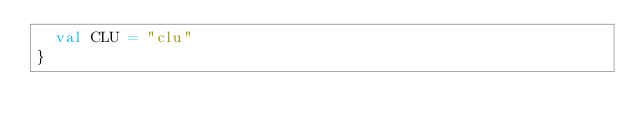Convert code to text. <code><loc_0><loc_0><loc_500><loc_500><_Scala_>  val CLU = "clu"
}
</code> 